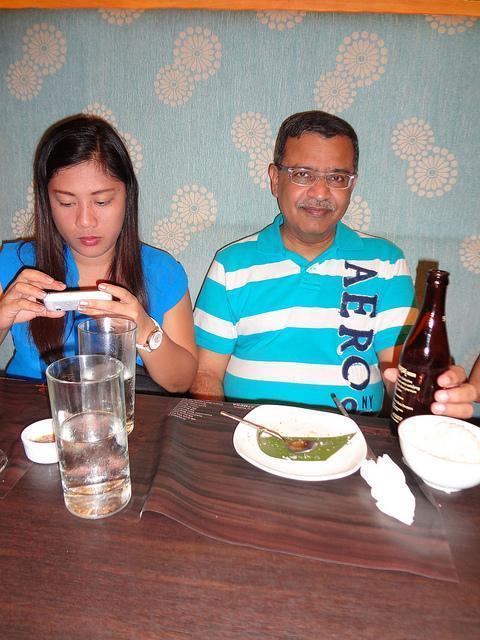How many cups can you see?
Give a very brief answer. 2. How many people are there?
Give a very brief answer. 2. 